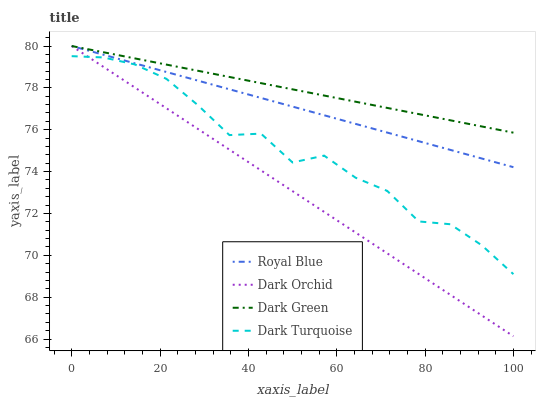Does Dark Orchid have the minimum area under the curve?
Answer yes or no. Yes. Does Dark Green have the maximum area under the curve?
Answer yes or no. Yes. Does Dark Turquoise have the minimum area under the curve?
Answer yes or no. No. Does Dark Turquoise have the maximum area under the curve?
Answer yes or no. No. Is Dark Orchid the smoothest?
Answer yes or no. Yes. Is Dark Turquoise the roughest?
Answer yes or no. Yes. Is Dark Turquoise the smoothest?
Answer yes or no. No. Is Dark Orchid the roughest?
Answer yes or no. No. Does Dark Orchid have the lowest value?
Answer yes or no. Yes. Does Dark Turquoise have the lowest value?
Answer yes or no. No. Does Dark Green have the highest value?
Answer yes or no. Yes. Does Dark Turquoise have the highest value?
Answer yes or no. No. Is Dark Turquoise less than Royal Blue?
Answer yes or no. Yes. Is Dark Green greater than Dark Turquoise?
Answer yes or no. Yes. Does Royal Blue intersect Dark Orchid?
Answer yes or no. Yes. Is Royal Blue less than Dark Orchid?
Answer yes or no. No. Is Royal Blue greater than Dark Orchid?
Answer yes or no. No. Does Dark Turquoise intersect Royal Blue?
Answer yes or no. No. 